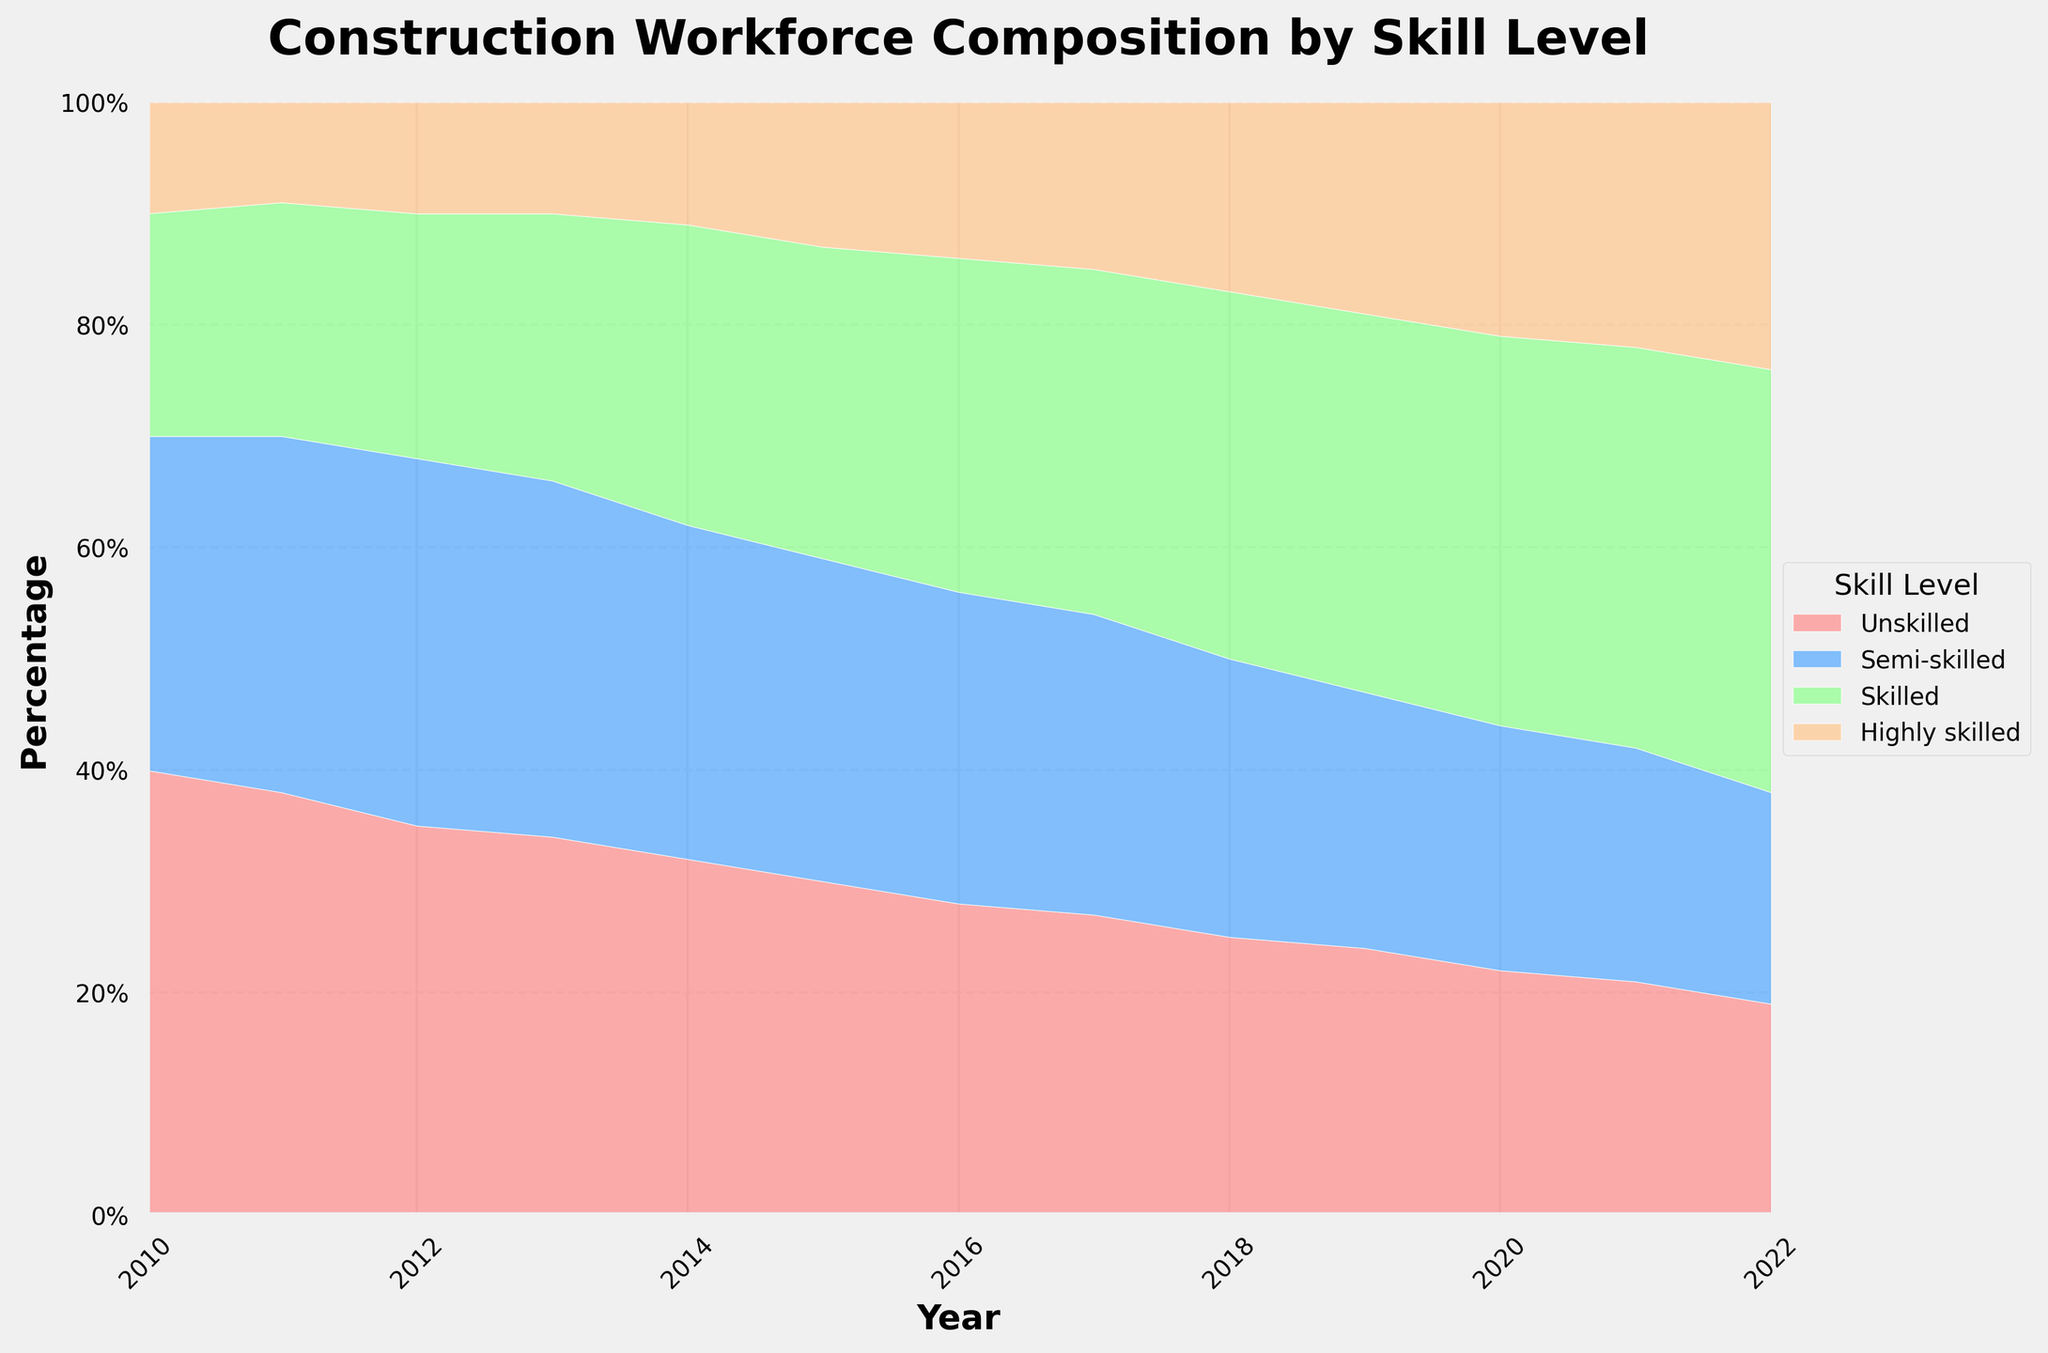What is the title of the chart? The title of the chart is usually displayed prominently at the top of the figure. For this figure, the title reads "Construction Workforce Composition by Skill Level."
Answer: Construction Workforce Composition by Skill Level What percentage of the workforce was highly skilled in 2022? To determine this, locate the year 2022 on the x-axis and find the topmost segment representing the "Highly skilled" category. The height of this segment will give the percentage directly by referring to the y-axis.
Answer: 24% How did the percentage of unskilled workers change from 2010 to 2022? Identify the segments for "Unskilled" workers at the year 2010 and 2022 by looking at the bottommost part of the chart. In 2010, it was 40%, and by 2022, it reduced to 19%. The change is found by calculating the difference, which is 40% - 19%.
Answer: Decreased by 21% What year had the highest percentage of semi-skilled workers? To find this, examine the second segment from the bottom, which represents the "Semi-skilled" category, across all the years. Compare the heights to determine the year with the maximum value.
Answer: 2012 Between which consecutive years did the percentage of skilled workers see the largest increase? Calculate the difference in the percentage of the "Skilled" category between each set of consecutive years and identify which gap is the largest. For example, from 2014 to 2015, there was a 1% increase, from 2012 to 2013 a 2% increase, etc.
Answer: 2017 to 2018 Compare the workforce composition between highly skilled and unskilled workers in 2020. Which was greater, and by how much? In 2020, refer to the segments representing "Highly skilled" (21%) and "Unskilled" (22%). The unskilled segment is slightly larger. Subtract the percentage of highly skilled from unskilled to get the difference.
Answer: Unskilled greater by 1% What is the average percentage of skilled workers from 2010 to 2022? To find the average percentage, sum the percentages of skilled workers across all the years (20 + 21 + 22 + 24 + 27 + 28 + 30 + 31 + 33 + 34 + 35 + 36 + 38) and then divide by the number of years (13).
Answer: 28% In which year did the workforce have the least percentage of semi-skilled workers? The lowest segment for the "Semi-skilled" category is compared across all years. By visual inspection, the shortest segment is seen in the year 2022 at 19%.
Answer: 2022 Is there any period where the percentage of highly skilled workers remained constant? Inspect the topmost segment for "Highly skilled" over the years. If any horizontal segment is observed, then that period had no change. For instance, from 2012 to 2013, the percentage remains at 10%.
Answer: 2012 to 2013 